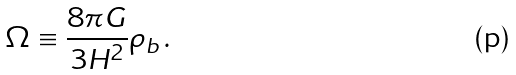<formula> <loc_0><loc_0><loc_500><loc_500>\Omega \equiv \frac { 8 \pi G } { 3 H ^ { 2 } } \rho _ { b } \, .</formula> 